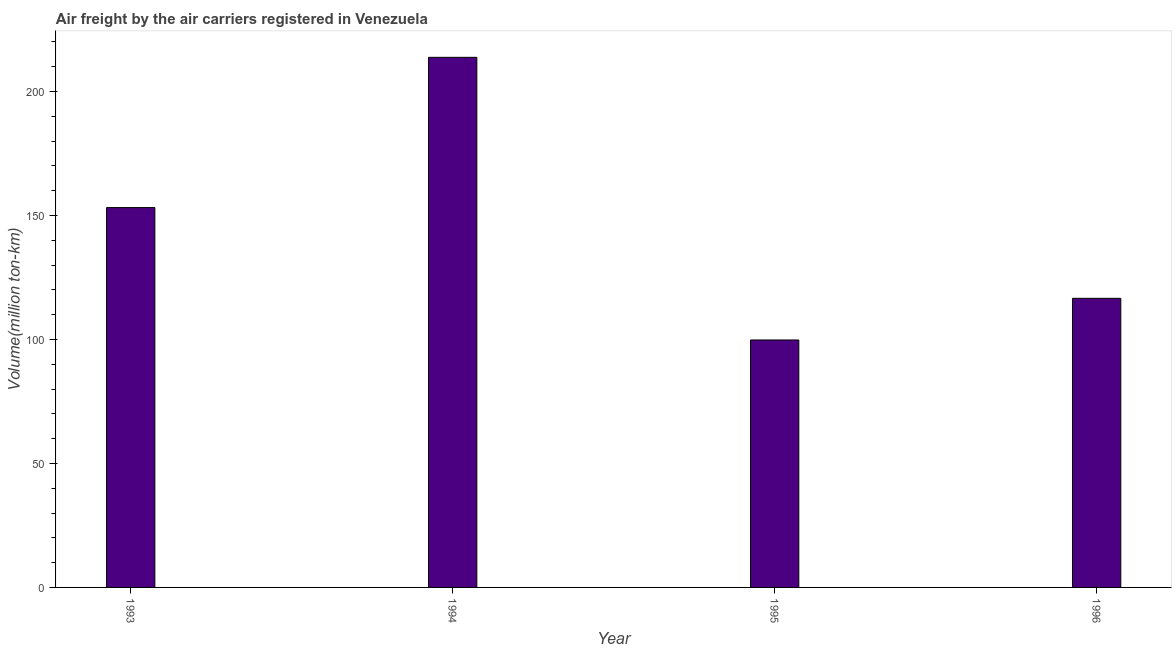Does the graph contain grids?
Ensure brevity in your answer.  No. What is the title of the graph?
Your answer should be compact. Air freight by the air carriers registered in Venezuela. What is the label or title of the Y-axis?
Provide a short and direct response. Volume(million ton-km). What is the air freight in 1996?
Your answer should be compact. 116.6. Across all years, what is the maximum air freight?
Your answer should be very brief. 213.8. Across all years, what is the minimum air freight?
Make the answer very short. 99.8. What is the sum of the air freight?
Provide a short and direct response. 583.4. What is the difference between the air freight in 1993 and 1996?
Give a very brief answer. 36.6. What is the average air freight per year?
Make the answer very short. 145.85. What is the median air freight?
Keep it short and to the point. 134.9. In how many years, is the air freight greater than 200 million ton-km?
Make the answer very short. 1. What is the ratio of the air freight in 1994 to that in 1996?
Offer a terse response. 1.83. Is the air freight in 1993 less than that in 1996?
Make the answer very short. No. What is the difference between the highest and the second highest air freight?
Provide a short and direct response. 60.6. What is the difference between the highest and the lowest air freight?
Your answer should be very brief. 114. In how many years, is the air freight greater than the average air freight taken over all years?
Your answer should be compact. 2. How many years are there in the graph?
Provide a succinct answer. 4. Are the values on the major ticks of Y-axis written in scientific E-notation?
Provide a succinct answer. No. What is the Volume(million ton-km) of 1993?
Ensure brevity in your answer.  153.2. What is the Volume(million ton-km) of 1994?
Keep it short and to the point. 213.8. What is the Volume(million ton-km) of 1995?
Offer a very short reply. 99.8. What is the Volume(million ton-km) of 1996?
Provide a short and direct response. 116.6. What is the difference between the Volume(million ton-km) in 1993 and 1994?
Give a very brief answer. -60.6. What is the difference between the Volume(million ton-km) in 1993 and 1995?
Offer a very short reply. 53.4. What is the difference between the Volume(million ton-km) in 1993 and 1996?
Offer a terse response. 36.6. What is the difference between the Volume(million ton-km) in 1994 and 1995?
Ensure brevity in your answer.  114. What is the difference between the Volume(million ton-km) in 1994 and 1996?
Your answer should be compact. 97.2. What is the difference between the Volume(million ton-km) in 1995 and 1996?
Your answer should be compact. -16.8. What is the ratio of the Volume(million ton-km) in 1993 to that in 1994?
Offer a very short reply. 0.72. What is the ratio of the Volume(million ton-km) in 1993 to that in 1995?
Make the answer very short. 1.53. What is the ratio of the Volume(million ton-km) in 1993 to that in 1996?
Offer a terse response. 1.31. What is the ratio of the Volume(million ton-km) in 1994 to that in 1995?
Give a very brief answer. 2.14. What is the ratio of the Volume(million ton-km) in 1994 to that in 1996?
Give a very brief answer. 1.83. What is the ratio of the Volume(million ton-km) in 1995 to that in 1996?
Offer a very short reply. 0.86. 